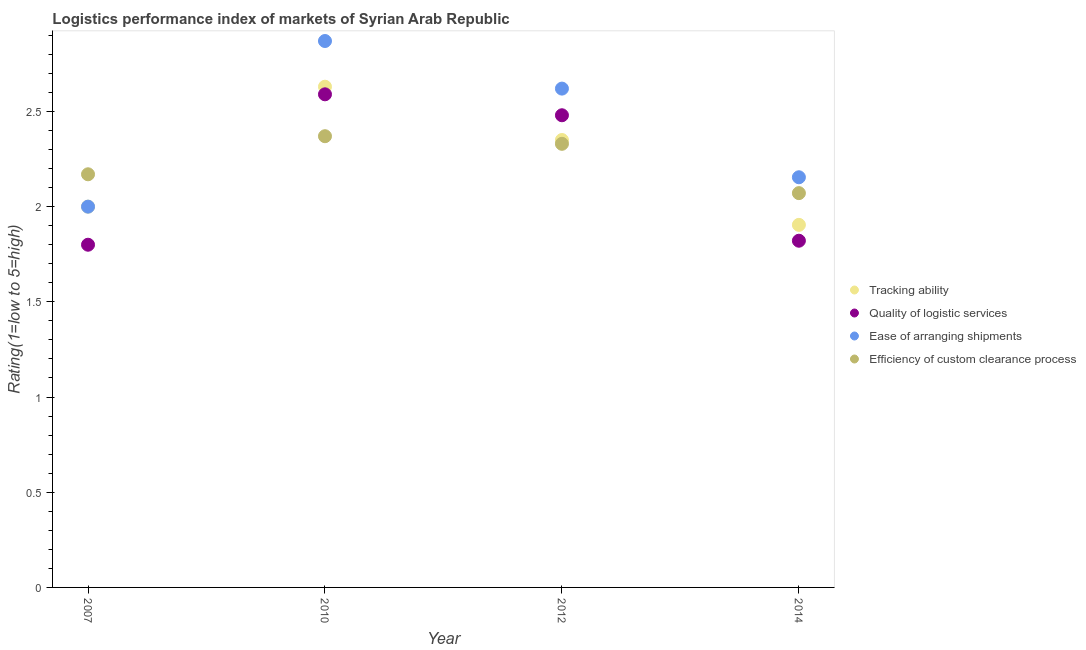What is the lpi rating of efficiency of custom clearance process in 2014?
Provide a short and direct response. 2.07. Across all years, what is the maximum lpi rating of tracking ability?
Give a very brief answer. 2.63. Across all years, what is the minimum lpi rating of efficiency of custom clearance process?
Provide a short and direct response. 2.07. In which year was the lpi rating of efficiency of custom clearance process minimum?
Keep it short and to the point. 2014. What is the total lpi rating of tracking ability in the graph?
Make the answer very short. 8.88. What is the difference between the lpi rating of quality of logistic services in 2010 and that in 2012?
Make the answer very short. 0.11. What is the difference between the lpi rating of tracking ability in 2010 and the lpi rating of quality of logistic services in 2014?
Make the answer very short. 0.81. What is the average lpi rating of efficiency of custom clearance process per year?
Offer a terse response. 2.24. In the year 2010, what is the difference between the lpi rating of tracking ability and lpi rating of quality of logistic services?
Keep it short and to the point. 0.04. In how many years, is the lpi rating of quality of logistic services greater than 1.6?
Your answer should be very brief. 4. What is the ratio of the lpi rating of quality of logistic services in 2012 to that in 2014?
Offer a terse response. 1.36. Is the difference between the lpi rating of tracking ability in 2010 and 2014 greater than the difference between the lpi rating of ease of arranging shipments in 2010 and 2014?
Ensure brevity in your answer.  Yes. What is the difference between the highest and the second highest lpi rating of quality of logistic services?
Your answer should be very brief. 0.11. What is the difference between the highest and the lowest lpi rating of ease of arranging shipments?
Keep it short and to the point. 0.87. In how many years, is the lpi rating of quality of logistic services greater than the average lpi rating of quality of logistic services taken over all years?
Offer a terse response. 2. Is the sum of the lpi rating of quality of logistic services in 2007 and 2012 greater than the maximum lpi rating of ease of arranging shipments across all years?
Make the answer very short. Yes. Does the lpi rating of quality of logistic services monotonically increase over the years?
Provide a short and direct response. No. Is the lpi rating of tracking ability strictly greater than the lpi rating of ease of arranging shipments over the years?
Ensure brevity in your answer.  No. How many dotlines are there?
Keep it short and to the point. 4. What is the difference between two consecutive major ticks on the Y-axis?
Your answer should be very brief. 0.5. Where does the legend appear in the graph?
Offer a terse response. Center right. How many legend labels are there?
Provide a short and direct response. 4. How are the legend labels stacked?
Your answer should be very brief. Vertical. What is the title of the graph?
Offer a very short reply. Logistics performance index of markets of Syrian Arab Republic. What is the label or title of the Y-axis?
Give a very brief answer. Rating(1=low to 5=high). What is the Rating(1=low to 5=high) of Quality of logistic services in 2007?
Give a very brief answer. 1.8. What is the Rating(1=low to 5=high) in Ease of arranging shipments in 2007?
Your response must be concise. 2. What is the Rating(1=low to 5=high) in Efficiency of custom clearance process in 2007?
Make the answer very short. 2.17. What is the Rating(1=low to 5=high) of Tracking ability in 2010?
Keep it short and to the point. 2.63. What is the Rating(1=low to 5=high) of Quality of logistic services in 2010?
Provide a succinct answer. 2.59. What is the Rating(1=low to 5=high) in Ease of arranging shipments in 2010?
Offer a terse response. 2.87. What is the Rating(1=low to 5=high) in Efficiency of custom clearance process in 2010?
Offer a terse response. 2.37. What is the Rating(1=low to 5=high) of Tracking ability in 2012?
Your answer should be very brief. 2.35. What is the Rating(1=low to 5=high) in Quality of logistic services in 2012?
Your response must be concise. 2.48. What is the Rating(1=low to 5=high) in Ease of arranging shipments in 2012?
Offer a terse response. 2.62. What is the Rating(1=low to 5=high) of Efficiency of custom clearance process in 2012?
Offer a terse response. 2.33. What is the Rating(1=low to 5=high) of Tracking ability in 2014?
Your response must be concise. 1.9. What is the Rating(1=low to 5=high) in Quality of logistic services in 2014?
Offer a very short reply. 1.82. What is the Rating(1=low to 5=high) of Ease of arranging shipments in 2014?
Your answer should be very brief. 2.15. What is the Rating(1=low to 5=high) of Efficiency of custom clearance process in 2014?
Your answer should be very brief. 2.07. Across all years, what is the maximum Rating(1=low to 5=high) in Tracking ability?
Your answer should be compact. 2.63. Across all years, what is the maximum Rating(1=low to 5=high) in Quality of logistic services?
Ensure brevity in your answer.  2.59. Across all years, what is the maximum Rating(1=low to 5=high) in Ease of arranging shipments?
Offer a terse response. 2.87. Across all years, what is the maximum Rating(1=low to 5=high) of Efficiency of custom clearance process?
Give a very brief answer. 2.37. Across all years, what is the minimum Rating(1=low to 5=high) of Tracking ability?
Your answer should be compact. 1.9. Across all years, what is the minimum Rating(1=low to 5=high) of Ease of arranging shipments?
Provide a short and direct response. 2. Across all years, what is the minimum Rating(1=low to 5=high) of Efficiency of custom clearance process?
Ensure brevity in your answer.  2.07. What is the total Rating(1=low to 5=high) of Tracking ability in the graph?
Provide a succinct answer. 8.88. What is the total Rating(1=low to 5=high) in Quality of logistic services in the graph?
Keep it short and to the point. 8.69. What is the total Rating(1=low to 5=high) of Ease of arranging shipments in the graph?
Make the answer very short. 9.64. What is the total Rating(1=low to 5=high) of Efficiency of custom clearance process in the graph?
Offer a terse response. 8.94. What is the difference between the Rating(1=low to 5=high) of Tracking ability in 2007 and that in 2010?
Your answer should be compact. -0.63. What is the difference between the Rating(1=low to 5=high) of Quality of logistic services in 2007 and that in 2010?
Keep it short and to the point. -0.79. What is the difference between the Rating(1=low to 5=high) of Ease of arranging shipments in 2007 and that in 2010?
Keep it short and to the point. -0.87. What is the difference between the Rating(1=low to 5=high) of Efficiency of custom clearance process in 2007 and that in 2010?
Your answer should be compact. -0.2. What is the difference between the Rating(1=low to 5=high) of Tracking ability in 2007 and that in 2012?
Make the answer very short. -0.35. What is the difference between the Rating(1=low to 5=high) in Quality of logistic services in 2007 and that in 2012?
Provide a succinct answer. -0.68. What is the difference between the Rating(1=low to 5=high) in Ease of arranging shipments in 2007 and that in 2012?
Offer a very short reply. -0.62. What is the difference between the Rating(1=low to 5=high) in Efficiency of custom clearance process in 2007 and that in 2012?
Offer a very short reply. -0.16. What is the difference between the Rating(1=low to 5=high) in Tracking ability in 2007 and that in 2014?
Keep it short and to the point. 0.1. What is the difference between the Rating(1=low to 5=high) in Quality of logistic services in 2007 and that in 2014?
Provide a succinct answer. -0.02. What is the difference between the Rating(1=low to 5=high) of Ease of arranging shipments in 2007 and that in 2014?
Provide a short and direct response. -0.15. What is the difference between the Rating(1=low to 5=high) of Efficiency of custom clearance process in 2007 and that in 2014?
Give a very brief answer. 0.1. What is the difference between the Rating(1=low to 5=high) of Tracking ability in 2010 and that in 2012?
Your response must be concise. 0.28. What is the difference between the Rating(1=low to 5=high) in Quality of logistic services in 2010 and that in 2012?
Make the answer very short. 0.11. What is the difference between the Rating(1=low to 5=high) in Tracking ability in 2010 and that in 2014?
Ensure brevity in your answer.  0.73. What is the difference between the Rating(1=low to 5=high) in Quality of logistic services in 2010 and that in 2014?
Your response must be concise. 0.77. What is the difference between the Rating(1=low to 5=high) in Ease of arranging shipments in 2010 and that in 2014?
Provide a short and direct response. 0.72. What is the difference between the Rating(1=low to 5=high) in Efficiency of custom clearance process in 2010 and that in 2014?
Provide a short and direct response. 0.3. What is the difference between the Rating(1=low to 5=high) of Tracking ability in 2012 and that in 2014?
Offer a terse response. 0.45. What is the difference between the Rating(1=low to 5=high) in Quality of logistic services in 2012 and that in 2014?
Your answer should be compact. 0.66. What is the difference between the Rating(1=low to 5=high) of Ease of arranging shipments in 2012 and that in 2014?
Your answer should be very brief. 0.47. What is the difference between the Rating(1=low to 5=high) in Efficiency of custom clearance process in 2012 and that in 2014?
Make the answer very short. 0.26. What is the difference between the Rating(1=low to 5=high) in Tracking ability in 2007 and the Rating(1=low to 5=high) in Quality of logistic services in 2010?
Provide a succinct answer. -0.59. What is the difference between the Rating(1=low to 5=high) in Tracking ability in 2007 and the Rating(1=low to 5=high) in Ease of arranging shipments in 2010?
Your answer should be very brief. -0.87. What is the difference between the Rating(1=low to 5=high) in Tracking ability in 2007 and the Rating(1=low to 5=high) in Efficiency of custom clearance process in 2010?
Offer a terse response. -0.37. What is the difference between the Rating(1=low to 5=high) in Quality of logistic services in 2007 and the Rating(1=low to 5=high) in Ease of arranging shipments in 2010?
Offer a terse response. -1.07. What is the difference between the Rating(1=low to 5=high) in Quality of logistic services in 2007 and the Rating(1=low to 5=high) in Efficiency of custom clearance process in 2010?
Ensure brevity in your answer.  -0.57. What is the difference between the Rating(1=low to 5=high) in Ease of arranging shipments in 2007 and the Rating(1=low to 5=high) in Efficiency of custom clearance process in 2010?
Ensure brevity in your answer.  -0.37. What is the difference between the Rating(1=low to 5=high) in Tracking ability in 2007 and the Rating(1=low to 5=high) in Quality of logistic services in 2012?
Provide a succinct answer. -0.48. What is the difference between the Rating(1=low to 5=high) in Tracking ability in 2007 and the Rating(1=low to 5=high) in Ease of arranging shipments in 2012?
Keep it short and to the point. -0.62. What is the difference between the Rating(1=low to 5=high) of Tracking ability in 2007 and the Rating(1=low to 5=high) of Efficiency of custom clearance process in 2012?
Provide a succinct answer. -0.33. What is the difference between the Rating(1=low to 5=high) in Quality of logistic services in 2007 and the Rating(1=low to 5=high) in Ease of arranging shipments in 2012?
Offer a very short reply. -0.82. What is the difference between the Rating(1=low to 5=high) of Quality of logistic services in 2007 and the Rating(1=low to 5=high) of Efficiency of custom clearance process in 2012?
Offer a very short reply. -0.53. What is the difference between the Rating(1=low to 5=high) of Ease of arranging shipments in 2007 and the Rating(1=low to 5=high) of Efficiency of custom clearance process in 2012?
Your answer should be compact. -0.33. What is the difference between the Rating(1=low to 5=high) in Tracking ability in 2007 and the Rating(1=low to 5=high) in Quality of logistic services in 2014?
Provide a short and direct response. 0.18. What is the difference between the Rating(1=low to 5=high) in Tracking ability in 2007 and the Rating(1=low to 5=high) in Ease of arranging shipments in 2014?
Make the answer very short. -0.15. What is the difference between the Rating(1=low to 5=high) in Tracking ability in 2007 and the Rating(1=low to 5=high) in Efficiency of custom clearance process in 2014?
Ensure brevity in your answer.  -0.07. What is the difference between the Rating(1=low to 5=high) in Quality of logistic services in 2007 and the Rating(1=low to 5=high) in Ease of arranging shipments in 2014?
Ensure brevity in your answer.  -0.35. What is the difference between the Rating(1=low to 5=high) of Quality of logistic services in 2007 and the Rating(1=low to 5=high) of Efficiency of custom clearance process in 2014?
Your answer should be very brief. -0.27. What is the difference between the Rating(1=low to 5=high) in Ease of arranging shipments in 2007 and the Rating(1=low to 5=high) in Efficiency of custom clearance process in 2014?
Offer a very short reply. -0.07. What is the difference between the Rating(1=low to 5=high) of Tracking ability in 2010 and the Rating(1=low to 5=high) of Quality of logistic services in 2012?
Offer a very short reply. 0.15. What is the difference between the Rating(1=low to 5=high) in Tracking ability in 2010 and the Rating(1=low to 5=high) in Ease of arranging shipments in 2012?
Provide a short and direct response. 0.01. What is the difference between the Rating(1=low to 5=high) of Quality of logistic services in 2010 and the Rating(1=low to 5=high) of Ease of arranging shipments in 2012?
Offer a terse response. -0.03. What is the difference between the Rating(1=low to 5=high) in Quality of logistic services in 2010 and the Rating(1=low to 5=high) in Efficiency of custom clearance process in 2012?
Provide a short and direct response. 0.26. What is the difference between the Rating(1=low to 5=high) in Ease of arranging shipments in 2010 and the Rating(1=low to 5=high) in Efficiency of custom clearance process in 2012?
Keep it short and to the point. 0.54. What is the difference between the Rating(1=low to 5=high) in Tracking ability in 2010 and the Rating(1=low to 5=high) in Quality of logistic services in 2014?
Your response must be concise. 0.81. What is the difference between the Rating(1=low to 5=high) of Tracking ability in 2010 and the Rating(1=low to 5=high) of Ease of arranging shipments in 2014?
Provide a succinct answer. 0.48. What is the difference between the Rating(1=low to 5=high) in Tracking ability in 2010 and the Rating(1=low to 5=high) in Efficiency of custom clearance process in 2014?
Give a very brief answer. 0.56. What is the difference between the Rating(1=low to 5=high) in Quality of logistic services in 2010 and the Rating(1=low to 5=high) in Ease of arranging shipments in 2014?
Your answer should be compact. 0.44. What is the difference between the Rating(1=low to 5=high) of Quality of logistic services in 2010 and the Rating(1=low to 5=high) of Efficiency of custom clearance process in 2014?
Give a very brief answer. 0.52. What is the difference between the Rating(1=low to 5=high) of Ease of arranging shipments in 2010 and the Rating(1=low to 5=high) of Efficiency of custom clearance process in 2014?
Keep it short and to the point. 0.8. What is the difference between the Rating(1=low to 5=high) of Tracking ability in 2012 and the Rating(1=low to 5=high) of Quality of logistic services in 2014?
Your response must be concise. 0.53. What is the difference between the Rating(1=low to 5=high) in Tracking ability in 2012 and the Rating(1=low to 5=high) in Ease of arranging shipments in 2014?
Your answer should be compact. 0.2. What is the difference between the Rating(1=low to 5=high) of Tracking ability in 2012 and the Rating(1=low to 5=high) of Efficiency of custom clearance process in 2014?
Your answer should be compact. 0.28. What is the difference between the Rating(1=low to 5=high) in Quality of logistic services in 2012 and the Rating(1=low to 5=high) in Ease of arranging shipments in 2014?
Your answer should be compact. 0.33. What is the difference between the Rating(1=low to 5=high) in Quality of logistic services in 2012 and the Rating(1=low to 5=high) in Efficiency of custom clearance process in 2014?
Keep it short and to the point. 0.41. What is the difference between the Rating(1=low to 5=high) of Ease of arranging shipments in 2012 and the Rating(1=low to 5=high) of Efficiency of custom clearance process in 2014?
Ensure brevity in your answer.  0.55. What is the average Rating(1=low to 5=high) in Tracking ability per year?
Provide a short and direct response. 2.22. What is the average Rating(1=low to 5=high) in Quality of logistic services per year?
Your answer should be compact. 2.17. What is the average Rating(1=low to 5=high) in Ease of arranging shipments per year?
Provide a succinct answer. 2.41. What is the average Rating(1=low to 5=high) of Efficiency of custom clearance process per year?
Your response must be concise. 2.24. In the year 2007, what is the difference between the Rating(1=low to 5=high) in Tracking ability and Rating(1=low to 5=high) in Efficiency of custom clearance process?
Provide a succinct answer. -0.17. In the year 2007, what is the difference between the Rating(1=low to 5=high) in Quality of logistic services and Rating(1=low to 5=high) in Ease of arranging shipments?
Your answer should be very brief. -0.2. In the year 2007, what is the difference between the Rating(1=low to 5=high) of Quality of logistic services and Rating(1=low to 5=high) of Efficiency of custom clearance process?
Ensure brevity in your answer.  -0.37. In the year 2007, what is the difference between the Rating(1=low to 5=high) in Ease of arranging shipments and Rating(1=low to 5=high) in Efficiency of custom clearance process?
Provide a short and direct response. -0.17. In the year 2010, what is the difference between the Rating(1=low to 5=high) of Tracking ability and Rating(1=low to 5=high) of Quality of logistic services?
Your response must be concise. 0.04. In the year 2010, what is the difference between the Rating(1=low to 5=high) of Tracking ability and Rating(1=low to 5=high) of Ease of arranging shipments?
Provide a short and direct response. -0.24. In the year 2010, what is the difference between the Rating(1=low to 5=high) of Tracking ability and Rating(1=low to 5=high) of Efficiency of custom clearance process?
Offer a terse response. 0.26. In the year 2010, what is the difference between the Rating(1=low to 5=high) in Quality of logistic services and Rating(1=low to 5=high) in Ease of arranging shipments?
Provide a succinct answer. -0.28. In the year 2010, what is the difference between the Rating(1=low to 5=high) in Quality of logistic services and Rating(1=low to 5=high) in Efficiency of custom clearance process?
Your answer should be compact. 0.22. In the year 2012, what is the difference between the Rating(1=low to 5=high) in Tracking ability and Rating(1=low to 5=high) in Quality of logistic services?
Ensure brevity in your answer.  -0.13. In the year 2012, what is the difference between the Rating(1=low to 5=high) in Tracking ability and Rating(1=low to 5=high) in Ease of arranging shipments?
Your answer should be compact. -0.27. In the year 2012, what is the difference between the Rating(1=low to 5=high) in Quality of logistic services and Rating(1=low to 5=high) in Ease of arranging shipments?
Make the answer very short. -0.14. In the year 2012, what is the difference between the Rating(1=low to 5=high) in Ease of arranging shipments and Rating(1=low to 5=high) in Efficiency of custom clearance process?
Your answer should be compact. 0.29. In the year 2014, what is the difference between the Rating(1=low to 5=high) in Tracking ability and Rating(1=low to 5=high) in Quality of logistic services?
Your answer should be compact. 0.08. In the year 2014, what is the difference between the Rating(1=low to 5=high) in Quality of logistic services and Rating(1=low to 5=high) in Efficiency of custom clearance process?
Provide a short and direct response. -0.25. In the year 2014, what is the difference between the Rating(1=low to 5=high) of Ease of arranging shipments and Rating(1=low to 5=high) of Efficiency of custom clearance process?
Provide a succinct answer. 0.08. What is the ratio of the Rating(1=low to 5=high) of Tracking ability in 2007 to that in 2010?
Your response must be concise. 0.76. What is the ratio of the Rating(1=low to 5=high) of Quality of logistic services in 2007 to that in 2010?
Keep it short and to the point. 0.69. What is the ratio of the Rating(1=low to 5=high) of Ease of arranging shipments in 2007 to that in 2010?
Make the answer very short. 0.7. What is the ratio of the Rating(1=low to 5=high) of Efficiency of custom clearance process in 2007 to that in 2010?
Your answer should be compact. 0.92. What is the ratio of the Rating(1=low to 5=high) in Tracking ability in 2007 to that in 2012?
Offer a very short reply. 0.85. What is the ratio of the Rating(1=low to 5=high) in Quality of logistic services in 2007 to that in 2012?
Make the answer very short. 0.73. What is the ratio of the Rating(1=low to 5=high) of Ease of arranging shipments in 2007 to that in 2012?
Provide a short and direct response. 0.76. What is the ratio of the Rating(1=low to 5=high) in Efficiency of custom clearance process in 2007 to that in 2012?
Offer a very short reply. 0.93. What is the ratio of the Rating(1=low to 5=high) in Tracking ability in 2007 to that in 2014?
Keep it short and to the point. 1.05. What is the ratio of the Rating(1=low to 5=high) of Quality of logistic services in 2007 to that in 2014?
Your answer should be compact. 0.99. What is the ratio of the Rating(1=low to 5=high) in Ease of arranging shipments in 2007 to that in 2014?
Keep it short and to the point. 0.93. What is the ratio of the Rating(1=low to 5=high) of Efficiency of custom clearance process in 2007 to that in 2014?
Offer a very short reply. 1.05. What is the ratio of the Rating(1=low to 5=high) of Tracking ability in 2010 to that in 2012?
Your response must be concise. 1.12. What is the ratio of the Rating(1=low to 5=high) of Quality of logistic services in 2010 to that in 2012?
Your response must be concise. 1.04. What is the ratio of the Rating(1=low to 5=high) in Ease of arranging shipments in 2010 to that in 2012?
Give a very brief answer. 1.1. What is the ratio of the Rating(1=low to 5=high) of Efficiency of custom clearance process in 2010 to that in 2012?
Offer a very short reply. 1.02. What is the ratio of the Rating(1=low to 5=high) of Tracking ability in 2010 to that in 2014?
Your answer should be compact. 1.38. What is the ratio of the Rating(1=low to 5=high) in Quality of logistic services in 2010 to that in 2014?
Your answer should be very brief. 1.42. What is the ratio of the Rating(1=low to 5=high) of Ease of arranging shipments in 2010 to that in 2014?
Offer a very short reply. 1.33. What is the ratio of the Rating(1=low to 5=high) of Efficiency of custom clearance process in 2010 to that in 2014?
Your answer should be compact. 1.14. What is the ratio of the Rating(1=low to 5=high) of Tracking ability in 2012 to that in 2014?
Ensure brevity in your answer.  1.23. What is the ratio of the Rating(1=low to 5=high) of Quality of logistic services in 2012 to that in 2014?
Give a very brief answer. 1.36. What is the ratio of the Rating(1=low to 5=high) of Ease of arranging shipments in 2012 to that in 2014?
Your response must be concise. 1.22. What is the ratio of the Rating(1=low to 5=high) of Efficiency of custom clearance process in 2012 to that in 2014?
Your answer should be compact. 1.13. What is the difference between the highest and the second highest Rating(1=low to 5=high) in Tracking ability?
Keep it short and to the point. 0.28. What is the difference between the highest and the second highest Rating(1=low to 5=high) in Quality of logistic services?
Ensure brevity in your answer.  0.11. What is the difference between the highest and the second highest Rating(1=low to 5=high) of Ease of arranging shipments?
Your answer should be very brief. 0.25. What is the difference between the highest and the lowest Rating(1=low to 5=high) of Tracking ability?
Your answer should be compact. 0.73. What is the difference between the highest and the lowest Rating(1=low to 5=high) of Quality of logistic services?
Make the answer very short. 0.79. What is the difference between the highest and the lowest Rating(1=low to 5=high) in Ease of arranging shipments?
Your answer should be very brief. 0.87. What is the difference between the highest and the lowest Rating(1=low to 5=high) in Efficiency of custom clearance process?
Give a very brief answer. 0.3. 